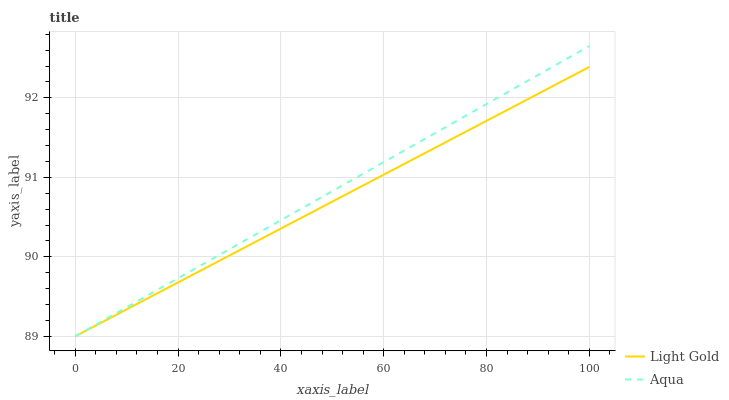Does Light Gold have the minimum area under the curve?
Answer yes or no. Yes. Does Aqua have the maximum area under the curve?
Answer yes or no. Yes. Does Light Gold have the maximum area under the curve?
Answer yes or no. No. Is Light Gold the smoothest?
Answer yes or no. Yes. Is Aqua the roughest?
Answer yes or no. Yes. Is Light Gold the roughest?
Answer yes or no. No. Does Aqua have the lowest value?
Answer yes or no. Yes. Does Aqua have the highest value?
Answer yes or no. Yes. Does Light Gold have the highest value?
Answer yes or no. No. Does Aqua intersect Light Gold?
Answer yes or no. Yes. Is Aqua less than Light Gold?
Answer yes or no. No. Is Aqua greater than Light Gold?
Answer yes or no. No. 